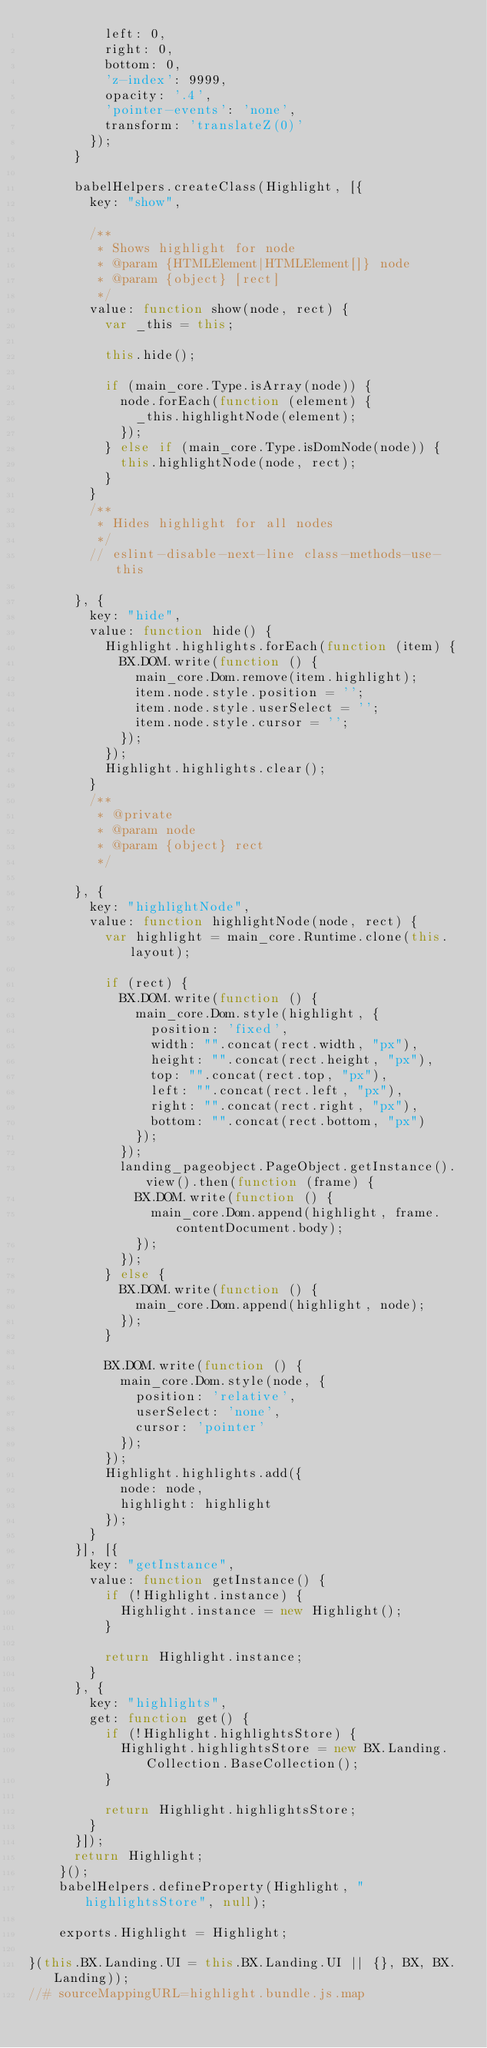<code> <loc_0><loc_0><loc_500><loc_500><_JavaScript_>	      left: 0,
	      right: 0,
	      bottom: 0,
	      'z-index': 9999,
	      opacity: '.4',
	      'pointer-events': 'none',
	      transform: 'translateZ(0)'
	    });
	  }

	  babelHelpers.createClass(Highlight, [{
	    key: "show",

	    /**
	     * Shows highlight for node
	     * @param {HTMLElement|HTMLElement[]} node
	     * @param {object} [rect]
	     */
	    value: function show(node, rect) {
	      var _this = this;

	      this.hide();

	      if (main_core.Type.isArray(node)) {
	        node.forEach(function (element) {
	          _this.highlightNode(element);
	        });
	      } else if (main_core.Type.isDomNode(node)) {
	        this.highlightNode(node, rect);
	      }
	    }
	    /**
	     * Hides highlight for all nodes
	     */
	    // eslint-disable-next-line class-methods-use-this

	  }, {
	    key: "hide",
	    value: function hide() {
	      Highlight.highlights.forEach(function (item) {
	        BX.DOM.write(function () {
	          main_core.Dom.remove(item.highlight);
	          item.node.style.position = '';
	          item.node.style.userSelect = '';
	          item.node.style.cursor = '';
	        });
	      });
	      Highlight.highlights.clear();
	    }
	    /**
	     * @private
	     * @param node
	     * @param {object} rect
	     */

	  }, {
	    key: "highlightNode",
	    value: function highlightNode(node, rect) {
	      var highlight = main_core.Runtime.clone(this.layout);

	      if (rect) {
	        BX.DOM.write(function () {
	          main_core.Dom.style(highlight, {
	            position: 'fixed',
	            width: "".concat(rect.width, "px"),
	            height: "".concat(rect.height, "px"),
	            top: "".concat(rect.top, "px"),
	            left: "".concat(rect.left, "px"),
	            right: "".concat(rect.right, "px"),
	            bottom: "".concat(rect.bottom, "px")
	          });
	        });
	        landing_pageobject.PageObject.getInstance().view().then(function (frame) {
	          BX.DOM.write(function () {
	            main_core.Dom.append(highlight, frame.contentDocument.body);
	          });
	        });
	      } else {
	        BX.DOM.write(function () {
	          main_core.Dom.append(highlight, node);
	        });
	      }

	      BX.DOM.write(function () {
	        main_core.Dom.style(node, {
	          position: 'relative',
	          userSelect: 'none',
	          cursor: 'pointer'
	        });
	      });
	      Highlight.highlights.add({
	        node: node,
	        highlight: highlight
	      });
	    }
	  }], [{
	    key: "getInstance",
	    value: function getInstance() {
	      if (!Highlight.instance) {
	        Highlight.instance = new Highlight();
	      }

	      return Highlight.instance;
	    }
	  }, {
	    key: "highlights",
	    get: function get() {
	      if (!Highlight.highlightsStore) {
	        Highlight.highlightsStore = new BX.Landing.Collection.BaseCollection();
	      }

	      return Highlight.highlightsStore;
	    }
	  }]);
	  return Highlight;
	}();
	babelHelpers.defineProperty(Highlight, "highlightsStore", null);

	exports.Highlight = Highlight;

}(this.BX.Landing.UI = this.BX.Landing.UI || {}, BX, BX.Landing));
//# sourceMappingURL=highlight.bundle.js.map
</code> 